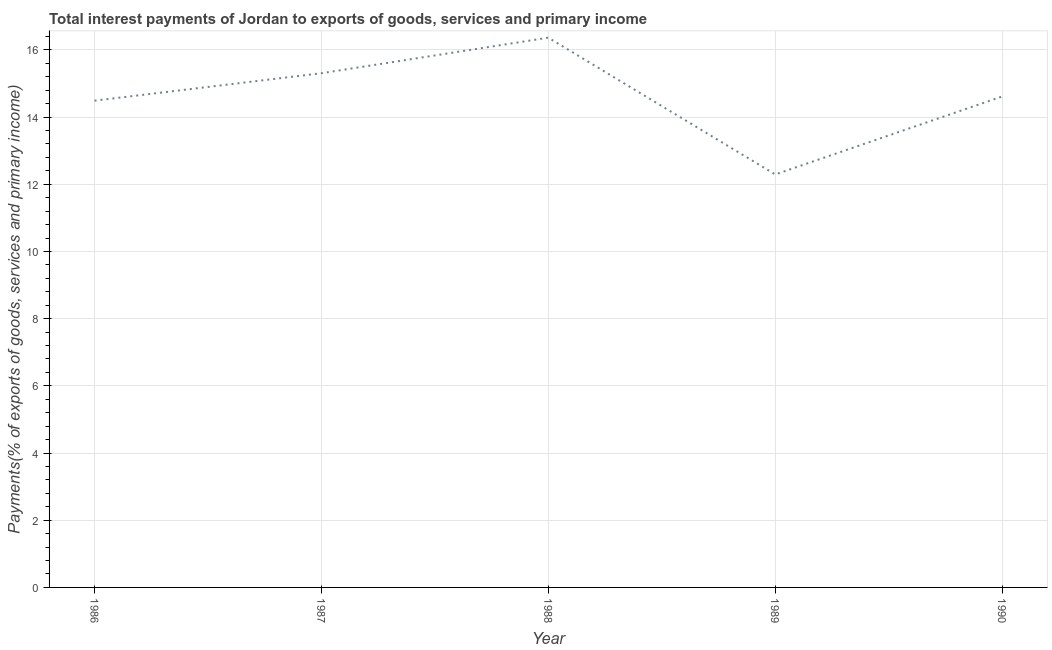What is the total interest payments on external debt in 1990?
Make the answer very short. 14.61. Across all years, what is the maximum total interest payments on external debt?
Provide a short and direct response. 16.36. Across all years, what is the minimum total interest payments on external debt?
Offer a terse response. 12.29. In which year was the total interest payments on external debt minimum?
Offer a terse response. 1989. What is the sum of the total interest payments on external debt?
Ensure brevity in your answer.  73.06. What is the difference between the total interest payments on external debt in 1986 and 1988?
Your answer should be compact. -1.88. What is the average total interest payments on external debt per year?
Keep it short and to the point. 14.61. What is the median total interest payments on external debt?
Your response must be concise. 14.61. Do a majority of the years between 1989 and 1986 (inclusive) have total interest payments on external debt greater than 11.6 %?
Your answer should be compact. Yes. What is the ratio of the total interest payments on external debt in 1986 to that in 1990?
Provide a succinct answer. 0.99. Is the total interest payments on external debt in 1988 less than that in 1989?
Your response must be concise. No. Is the difference between the total interest payments on external debt in 1986 and 1988 greater than the difference between any two years?
Make the answer very short. No. What is the difference between the highest and the second highest total interest payments on external debt?
Ensure brevity in your answer.  1.06. What is the difference between the highest and the lowest total interest payments on external debt?
Your answer should be very brief. 4.07. In how many years, is the total interest payments on external debt greater than the average total interest payments on external debt taken over all years?
Provide a succinct answer. 3. How many years are there in the graph?
Provide a succinct answer. 5. Are the values on the major ticks of Y-axis written in scientific E-notation?
Keep it short and to the point. No. Does the graph contain any zero values?
Provide a short and direct response. No. Does the graph contain grids?
Provide a succinct answer. Yes. What is the title of the graph?
Provide a short and direct response. Total interest payments of Jordan to exports of goods, services and primary income. What is the label or title of the Y-axis?
Provide a succinct answer. Payments(% of exports of goods, services and primary income). What is the Payments(% of exports of goods, services and primary income) of 1986?
Keep it short and to the point. 14.49. What is the Payments(% of exports of goods, services and primary income) of 1987?
Offer a very short reply. 15.3. What is the Payments(% of exports of goods, services and primary income) of 1988?
Offer a very short reply. 16.36. What is the Payments(% of exports of goods, services and primary income) in 1989?
Your response must be concise. 12.29. What is the Payments(% of exports of goods, services and primary income) in 1990?
Provide a short and direct response. 14.61. What is the difference between the Payments(% of exports of goods, services and primary income) in 1986 and 1987?
Your response must be concise. -0.82. What is the difference between the Payments(% of exports of goods, services and primary income) in 1986 and 1988?
Provide a short and direct response. -1.88. What is the difference between the Payments(% of exports of goods, services and primary income) in 1986 and 1989?
Ensure brevity in your answer.  2.2. What is the difference between the Payments(% of exports of goods, services and primary income) in 1986 and 1990?
Your answer should be compact. -0.12. What is the difference between the Payments(% of exports of goods, services and primary income) in 1987 and 1988?
Offer a terse response. -1.06. What is the difference between the Payments(% of exports of goods, services and primary income) in 1987 and 1989?
Provide a short and direct response. 3.01. What is the difference between the Payments(% of exports of goods, services and primary income) in 1987 and 1990?
Your answer should be compact. 0.69. What is the difference between the Payments(% of exports of goods, services and primary income) in 1988 and 1989?
Make the answer very short. 4.07. What is the difference between the Payments(% of exports of goods, services and primary income) in 1988 and 1990?
Make the answer very short. 1.75. What is the difference between the Payments(% of exports of goods, services and primary income) in 1989 and 1990?
Offer a terse response. -2.32. What is the ratio of the Payments(% of exports of goods, services and primary income) in 1986 to that in 1987?
Your response must be concise. 0.95. What is the ratio of the Payments(% of exports of goods, services and primary income) in 1986 to that in 1988?
Provide a short and direct response. 0.89. What is the ratio of the Payments(% of exports of goods, services and primary income) in 1986 to that in 1989?
Ensure brevity in your answer.  1.18. What is the ratio of the Payments(% of exports of goods, services and primary income) in 1986 to that in 1990?
Give a very brief answer. 0.99. What is the ratio of the Payments(% of exports of goods, services and primary income) in 1987 to that in 1988?
Provide a short and direct response. 0.94. What is the ratio of the Payments(% of exports of goods, services and primary income) in 1987 to that in 1989?
Provide a succinct answer. 1.25. What is the ratio of the Payments(% of exports of goods, services and primary income) in 1987 to that in 1990?
Offer a very short reply. 1.05. What is the ratio of the Payments(% of exports of goods, services and primary income) in 1988 to that in 1989?
Your answer should be compact. 1.33. What is the ratio of the Payments(% of exports of goods, services and primary income) in 1988 to that in 1990?
Offer a very short reply. 1.12. What is the ratio of the Payments(% of exports of goods, services and primary income) in 1989 to that in 1990?
Ensure brevity in your answer.  0.84. 